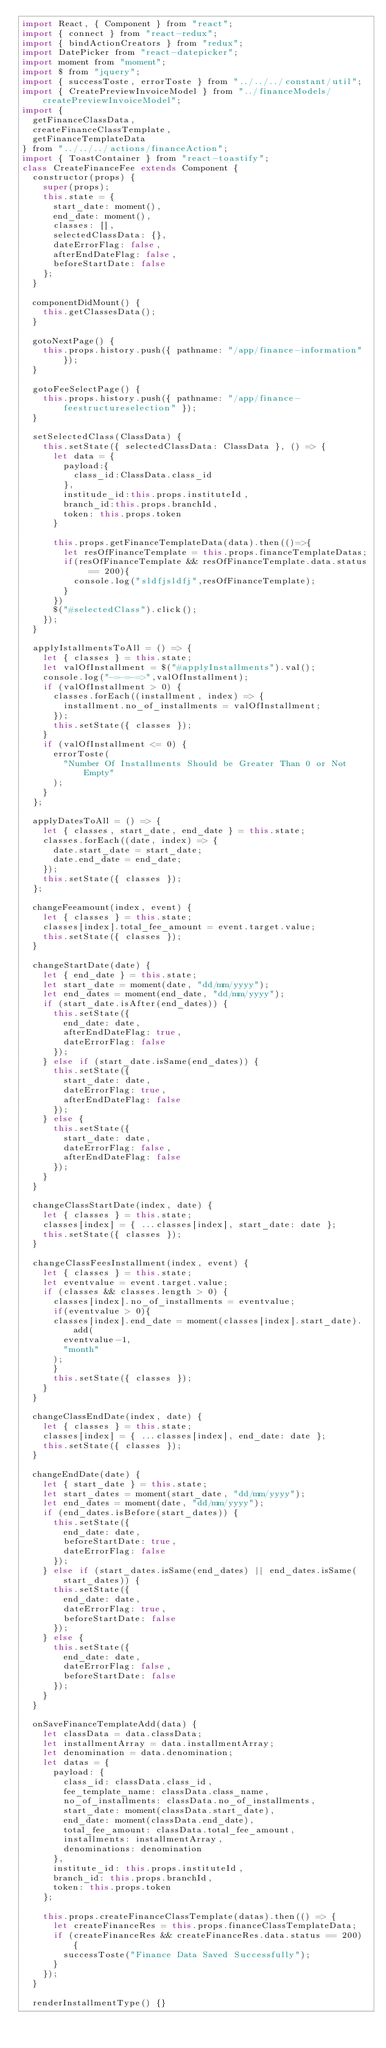Convert code to text. <code><loc_0><loc_0><loc_500><loc_500><_JavaScript_>import React, { Component } from "react";
import { connect } from "react-redux";
import { bindActionCreators } from "redux";
import DatePicker from "react-datepicker";
import moment from "moment";
import $ from "jquery";
import { successToste, errorToste } from "../../../constant/util";
import { CreatePreviewInvoiceModel } from "../financeModels/createPreviewInvoiceModel";
import {
  getFinanceClassData,
  createFinanceClassTemplate,
  getFinanceTemplateData
} from "../../../actions/financeAction";
import { ToastContainer } from "react-toastify";
class CreateFinanceFee extends Component {
  constructor(props) {
    super(props);
    this.state = {
      start_date: moment(),
      end_date: moment(),
      classes: [],
      selectedClassData: {},
      dateErrorFlag: false,
      afterEndDateFlag: false,
      beforeStartDate: false
    };
  }

  componentDidMount() {
    this.getClassesData();
  }

  gotoNextPage() {
    this.props.history.push({ pathname: "/app/finance-information" });
  }

  gotoFeeSelectPage() {
    this.props.history.push({ pathname: "/app/finance-feestructureselection" });
  }

  setSelectedClass(ClassData) {
    this.setState({ selectedClassData: ClassData }, () => {
      let data = {
        payload:{
          class_id:ClassData.class_id
        },
        institude_id:this.props.instituteId,
        branch_id:this.props.branchId,
        token: this.props.token
      }

      this.props.getFinanceTemplateData(data).then(()=>{
        let resOfFinanceTemplate = this.props.financeTemplateDatas;
        if(resOfFinanceTemplate && resOfFinanceTemplate.data.status == 200){
          console.log("sldfjsldfj",resOfFinanceTemplate);
        }
      })
      $("#selectedClass").click();
    });
  }

  applyIstallmentsToAll = () => {
    let { classes } = this.state;
    let valOfInstallment = $("#applyInstallments").val();
    console.log("-=-=-=>",valOfInstallment);
    if (valOfInstallment > 0) {
      classes.forEach((installment, index) => {
        installment.no_of_installments = valOfInstallment;
      });
      this.setState({ classes });
    }
    if (valOfInstallment <= 0) {
      errorToste(
        "Number Of Installments Should be Greater Than 0 or Not Empty"
      );
    }
  };

  applyDatesToAll = () => {
    let { classes, start_date, end_date } = this.state;
    classes.forEach((date, index) => {
      date.start_date = start_date;
      date.end_date = end_date;
    });
    this.setState({ classes });
  };

  changeFeeamount(index, event) {
    let { classes } = this.state;
    classes[index].total_fee_amount = event.target.value;
    this.setState({ classes });
  }

  changeStartDate(date) {
    let { end_date } = this.state;
    let start_date = moment(date, "dd/mm/yyyy");
    let end_dates = moment(end_date, "dd/mm/yyyy");
    if (start_date.isAfter(end_dates)) {
      this.setState({
        end_date: date,
        afterEndDateFlag: true,
        dateErrorFlag: false
      });
    } else if (start_date.isSame(end_dates)) {
      this.setState({
        start_date: date,
        dateErrorFlag: true,
        afterEndDateFlag: false
      });
    } else {
      this.setState({
        start_date: date,
        dateErrorFlag: false,
        afterEndDateFlag: false
      });
    }
  }

  changeClassStartDate(index, date) {
    let { classes } = this.state;
    classes[index] = { ...classes[index], start_date: date };
    this.setState({ classes });
  }

  changeClassFeesInstallment(index, event) {
    let { classes } = this.state;
    let eventvalue = event.target.value;
    if (classes && classes.length > 0) {
      classes[index].no_of_installments = eventvalue;
      if(eventvalue > 0){
      classes[index].end_date = moment(classes[index].start_date).add(
        eventvalue-1,
        "month"
      );
      }
      this.setState({ classes });
    }
  }

  changeClassEndDate(index, date) {
    let { classes } = this.state;
    classes[index] = { ...classes[index], end_date: date };
    this.setState({ classes });
  }

  changeEndDate(date) {
    let { start_date } = this.state;
    let start_dates = moment(start_date, "dd/mm/yyyy");
    let end_dates = moment(date, "dd/mm/yyyy");
    if (end_dates.isBefore(start_dates)) {
      this.setState({
        end_date: date,
        beforeStartDate: true,
        dateErrorFlag: false
      });
    } else if (start_dates.isSame(end_dates) || end_dates.isSame(start_dates)) {
      this.setState({
        end_date: date,
        dateErrorFlag: true,
        beforeStartDate: false
      });
    } else {
      this.setState({
        end_date: date,
        dateErrorFlag: false,
        beforeStartDate: false
      });
    }
  }

  onSaveFinanceTemplateAdd(data) {
    let classData = data.classData;
    let installmentArray = data.installmentArray;
    let denomination = data.denomination;
    let datas = {
      payload: {
        class_id: classData.class_id,
        fee_template_name: classData.class_name,
        no_of_installments: classData.no_of_installments,
        start_date: moment(classData.start_date),
        end_date: moment(classData.end_date),
        total_fee_amount: classData.total_fee_amount,
        installments: installmentArray,
        denominations: denomination
      },
      institute_id: this.props.instituteId,
      branch_id: this.props.branchId,
      token: this.props.token
    };

    this.props.createFinanceClassTemplate(datas).then(() => {
      let createFinanceRes = this.props.financeClassTemplateData;
      if (createFinanceRes && createFinanceRes.data.status == 200) {
        successToste("Finance Data Saved Successfully");
      }
    });
  }

  renderInstallmentType() {}
</code> 